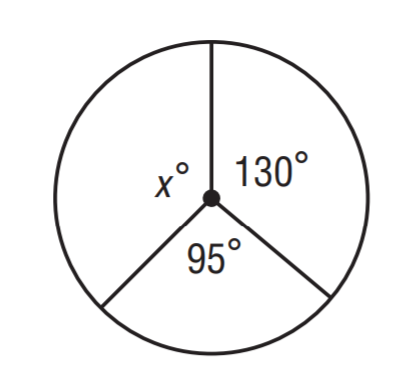Question: Find x.
Choices:
A. 120
B. 135
C. 145
D. 160
Answer with the letter. Answer: B 